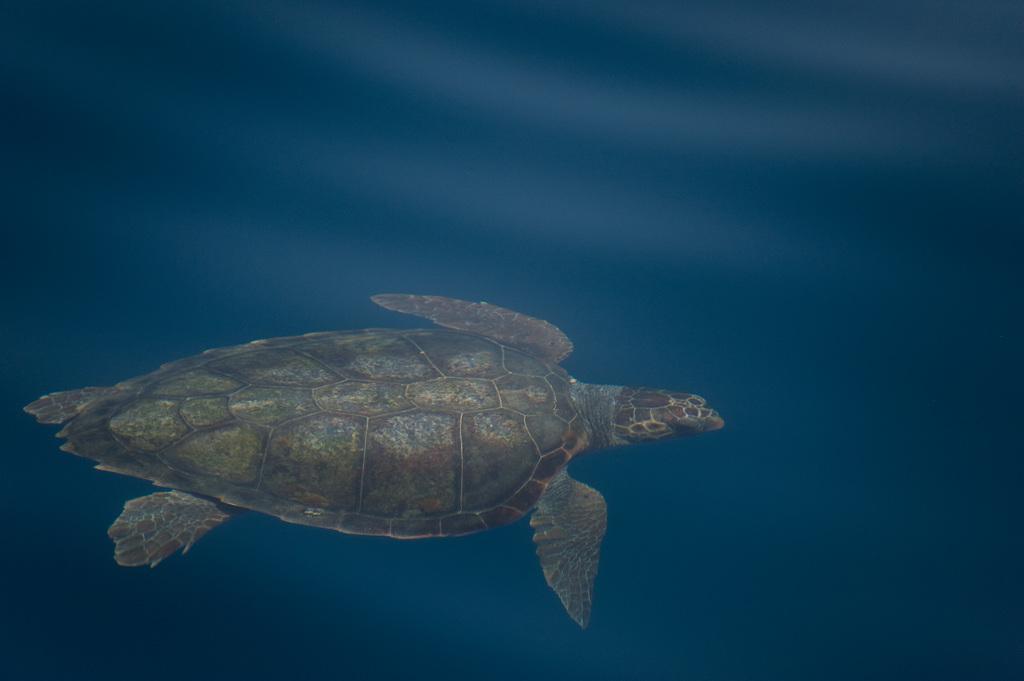Please provide a concise description of this image. In this image there is a turtle in the water. 